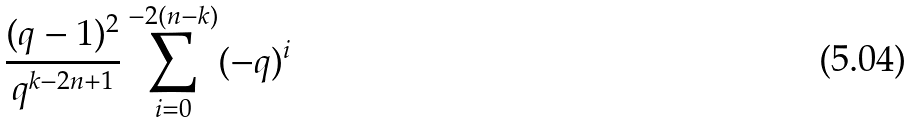Convert formula to latex. <formula><loc_0><loc_0><loc_500><loc_500>\frac { ( q - 1 ) ^ { 2 } } { q ^ { k - 2 n + 1 } } \sum _ { i = 0 } ^ { - 2 ( n - k ) } ( - q ) ^ { i }</formula> 